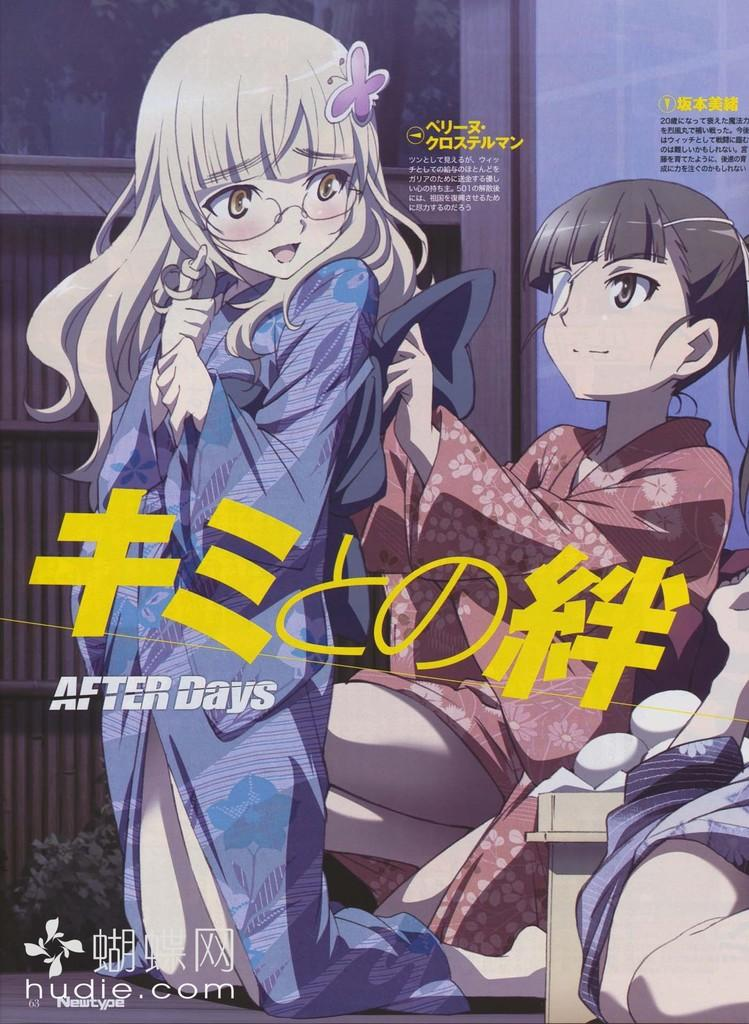What type of images are present in the picture? There are cartoon images in the picture. Is there any written content in the picture? Yes, there is text on the picture. Can you describe the location of the text in the picture? There is text at the bottom left corner of the picture. What type of dog can be seen in the picture? There is no dog present in the picture; it features cartoon images and text. How many clouds are visible in the picture? There are no clouds visible in the picture; it contains cartoon images and text. 